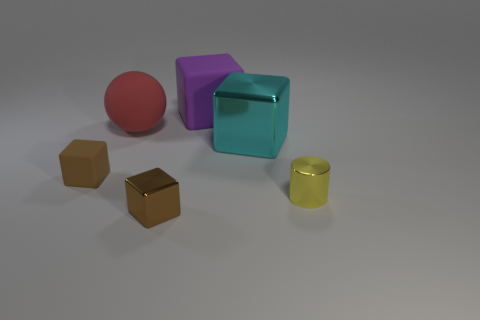There is a brown matte object; does it have the same shape as the large rubber object to the right of the tiny brown metal object?
Make the answer very short. Yes. There is a matte thing that is both in front of the purple object and to the right of the tiny rubber cube; what is its color?
Keep it short and to the point. Red. Are there any blue things of the same shape as the large cyan shiny object?
Offer a very short reply. No. Does the big matte block have the same color as the small cylinder?
Provide a short and direct response. No. Are there any metal cylinders in front of the tiny shiny thing that is behind the brown metallic block?
Offer a very short reply. No. What number of objects are large rubber objects in front of the large purple matte object or things on the right side of the brown shiny cube?
Provide a succinct answer. 4. How many things are matte things or small objects on the right side of the big purple cube?
Your answer should be compact. 4. There is a matte block in front of the rubber cube on the right side of the shiny cube left of the purple rubber object; how big is it?
Give a very brief answer. Small. There is a cube that is the same size as the purple thing; what is it made of?
Provide a succinct answer. Metal. Is there a yellow metal cylinder that has the same size as the purple matte block?
Ensure brevity in your answer.  No. 